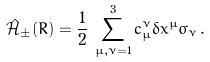<formula> <loc_0><loc_0><loc_500><loc_500>\hat { \mathcal { H } } _ { \pm } ( R ) = \frac { 1 } { 2 } \, \sum _ { \mu , \nu = 1 } ^ { 3 } c _ { \mu } ^ { \nu } \delta x ^ { \mu } \sigma _ { \nu } \, .</formula> 